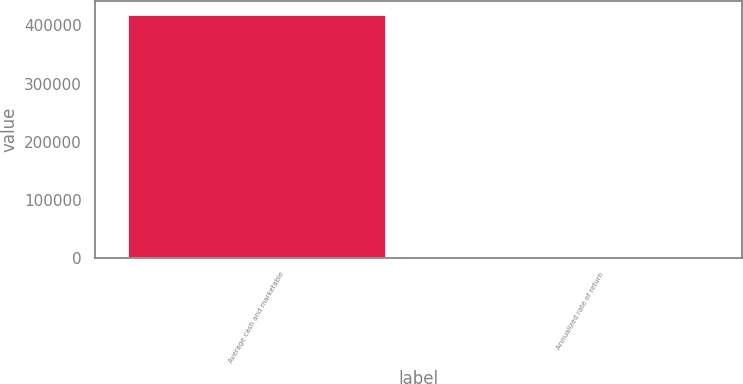Convert chart to OTSL. <chart><loc_0><loc_0><loc_500><loc_500><bar_chart><fcel>Average cash and marketable<fcel>Annualized rate of return<nl><fcel>420184<fcel>5.7<nl></chart> 